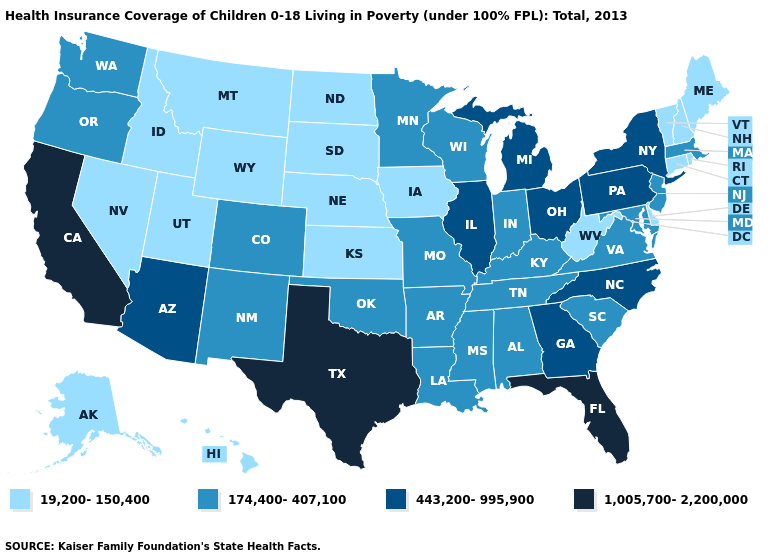Among the states that border Rhode Island , which have the lowest value?
Answer briefly. Connecticut. Does North Dakota have the lowest value in the MidWest?
Write a very short answer. Yes. Among the states that border Louisiana , does Texas have the lowest value?
Give a very brief answer. No. Does Connecticut have the highest value in the USA?
Be succinct. No. Does Wyoming have the lowest value in the USA?
Write a very short answer. Yes. Name the states that have a value in the range 174,400-407,100?
Keep it brief. Alabama, Arkansas, Colorado, Indiana, Kentucky, Louisiana, Maryland, Massachusetts, Minnesota, Mississippi, Missouri, New Jersey, New Mexico, Oklahoma, Oregon, South Carolina, Tennessee, Virginia, Washington, Wisconsin. What is the value of Pennsylvania?
Be succinct. 443,200-995,900. Which states have the highest value in the USA?
Concise answer only. California, Florida, Texas. Does Maine have a lower value than Kansas?
Concise answer only. No. How many symbols are there in the legend?
Answer briefly. 4. What is the value of Virginia?
Give a very brief answer. 174,400-407,100. What is the value of Nevada?
Answer briefly. 19,200-150,400. Name the states that have a value in the range 1,005,700-2,200,000?
Give a very brief answer. California, Florida, Texas. Name the states that have a value in the range 174,400-407,100?
Write a very short answer. Alabama, Arkansas, Colorado, Indiana, Kentucky, Louisiana, Maryland, Massachusetts, Minnesota, Mississippi, Missouri, New Jersey, New Mexico, Oklahoma, Oregon, South Carolina, Tennessee, Virginia, Washington, Wisconsin. 